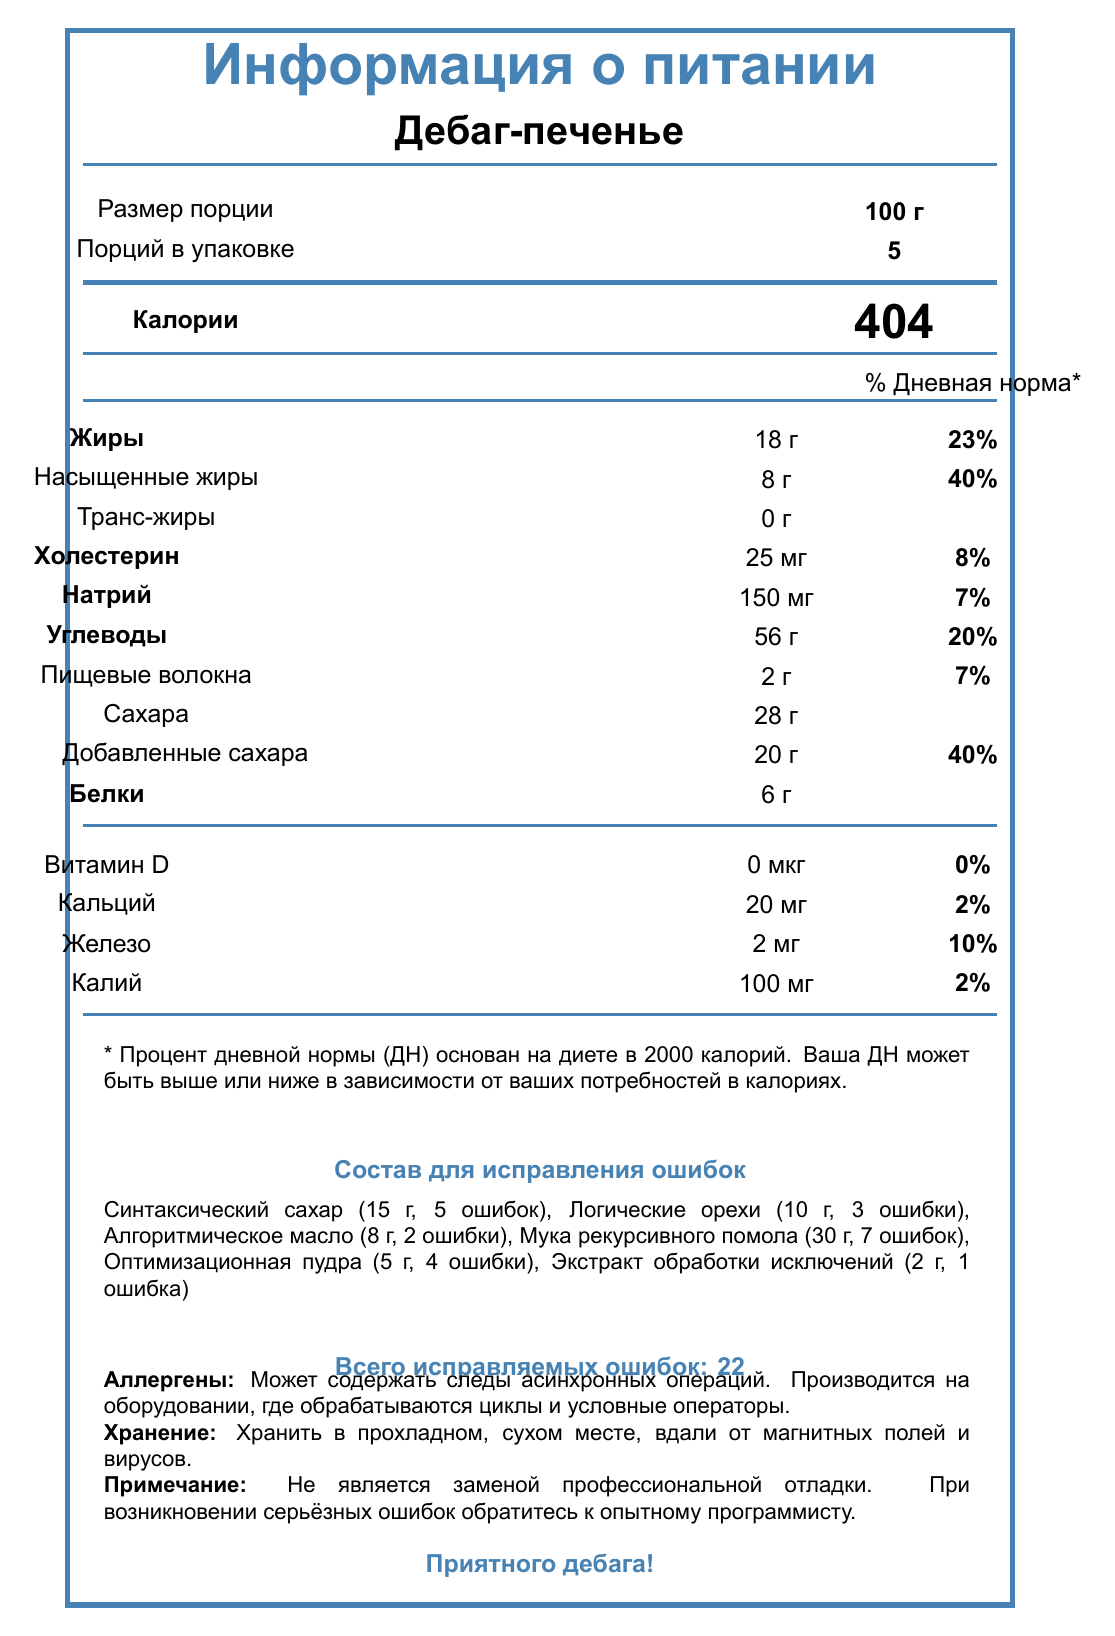what is the serving size of "Дебаг-печенье"? The serving size is mentioned next to the label "Размер порции", which indicates 100 г.
Answer: 100 г how many servings are there per container? The label "Порций в упаковке" shows that there are 5 servings per container.
Answer: 5 how many calories are in one serving of "Дебаг-печенье"? The document states in the section below the heading that one serving contains 404 calories.
Answer: 404 what is the total fat content in one serving? The total fat content is provided as 18 г next to the "Жиры" label.
Answer: 18 г what percentage of the daily value is the saturated fat content in one serving? The saturated fat content is listed as 8 г, which is 40% of the daily value.
Answer: 40% how much of "Синтаксический сахар" is used, and how many errors does it fix? "Синтаксический сахар" is used in the amount of 15 г and it fixes 5 errors as shown in the "Состав для исправления ошибок" section.
Answer: 15 г, 5 errors which ingredient fixes the most errors? A. Синтаксический сахар B. Логические орехи C. Мука рекурсивного помола D. Оптимизационная пудра "Мука рекурсивного помола" fixes 7 errors, which is the most among the listed ingredients.
Answer: C what is the total amount of sugars in one serving? The total sugars in one serving are 28 г as shown next to the "Сахара" label.
Answer: 28 г what is the percentage of daily value for dietary fiber in one serving? A. 7% B. 10% C. 23% D. 40% The dietary fiber content is 2 г, which constitutes 7% of the daily value.
Answer: A how should "Дебаг-печенье" be stored? The storage instructions are explicitly mentioned in the document.
Answer: Хранить в прохладном, сухом месте, вдали от магнитных полей и вирусов is "Дебаг-печенье" a replacement for professional debugging? The disclaimer states that it is not a replacement for professional debugging.
Answer: No does "Дебаг-печенье" contain any allergens? It may contain traces of asynchronous operations and is produced on equipment that processes loops and conditional operators.
Answer: Yes what is the total number of errors fixed by all ingredients? The document mentions a total of 22 errors fixed in the "Всего исправляемых ошибок" section.
Answer: 22 what are the allergen components potentially present in "Дебаг-печенье"? The document says it may contain traces of asynchronous operations and is produced on equipment processed with loops and conditional operators.
Answer: Асинхронные операции, циклы и условные операторы how much protein is there in one serving of "Дебаг-печенье"? The protein content is listed as 6 г in the document.
Answer: 6 г what percentage of daily value of calcium does one serving of "Дебаг-печенье" provide? The calcium content is 20 мг, which contributes to 2% of the daily value.
Answer: 2% what does the document mainly describe? This is summarized from sections including "Информация о питании", "Состав для исправления ошибок", and descriptions about allergens and storage.
Answer: The document provides nutritional information, ingredients, error-fixing capabilities, allergen information, and storage instructions for "Дебаг-печенье". what are the ingredients used in "Дебаг-печенье"? The specific ingredients of the cookie itself are not listed in the document; only the error-fixing ingredients are mentioned.
Answer: Cannot be determined 